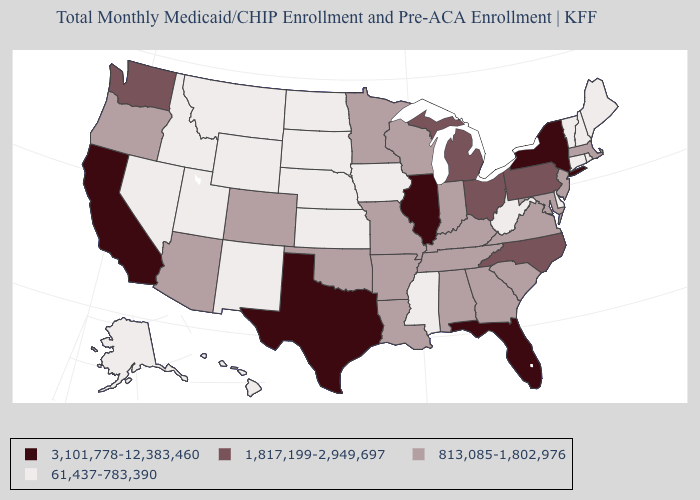Name the states that have a value in the range 61,437-783,390?
Write a very short answer. Alaska, Connecticut, Delaware, Hawaii, Idaho, Iowa, Kansas, Maine, Mississippi, Montana, Nebraska, Nevada, New Hampshire, New Mexico, North Dakota, Rhode Island, South Dakota, Utah, Vermont, West Virginia, Wyoming. Name the states that have a value in the range 813,085-1,802,976?
Short answer required. Alabama, Arizona, Arkansas, Colorado, Georgia, Indiana, Kentucky, Louisiana, Maryland, Massachusetts, Minnesota, Missouri, New Jersey, Oklahoma, Oregon, South Carolina, Tennessee, Virginia, Wisconsin. What is the value of Massachusetts?
Write a very short answer. 813,085-1,802,976. Does Minnesota have the highest value in the USA?
Write a very short answer. No. What is the value of Missouri?
Be succinct. 813,085-1,802,976. What is the value of Delaware?
Concise answer only. 61,437-783,390. Name the states that have a value in the range 61,437-783,390?
Short answer required. Alaska, Connecticut, Delaware, Hawaii, Idaho, Iowa, Kansas, Maine, Mississippi, Montana, Nebraska, Nevada, New Hampshire, New Mexico, North Dakota, Rhode Island, South Dakota, Utah, Vermont, West Virginia, Wyoming. What is the value of Florida?
Answer briefly. 3,101,778-12,383,460. Does the first symbol in the legend represent the smallest category?
Give a very brief answer. No. Does North Dakota have a higher value than Florida?
Keep it brief. No. What is the lowest value in the MidWest?
Be succinct. 61,437-783,390. What is the value of South Dakota?
Be succinct. 61,437-783,390. What is the value of Connecticut?
Short answer required. 61,437-783,390. Name the states that have a value in the range 1,817,199-2,949,697?
Short answer required. Michigan, North Carolina, Ohio, Pennsylvania, Washington. What is the lowest value in the Northeast?
Quick response, please. 61,437-783,390. 